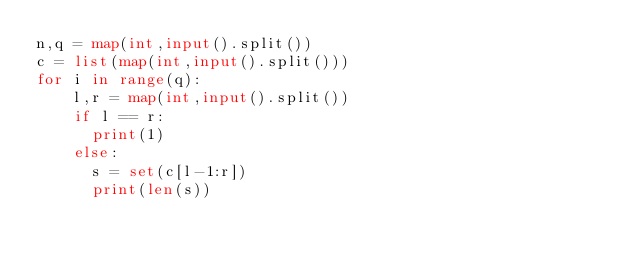Convert code to text. <code><loc_0><loc_0><loc_500><loc_500><_Python_>n,q = map(int,input().split())
c = list(map(int,input().split()))
for i in range(q):
    l,r = map(int,input().split())
    if l == r:
      print(1)
    else:
      s = set(c[l-1:r])
      print(len(s))</code> 